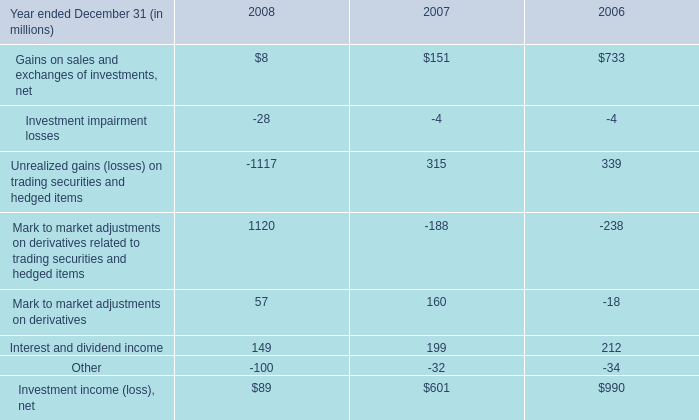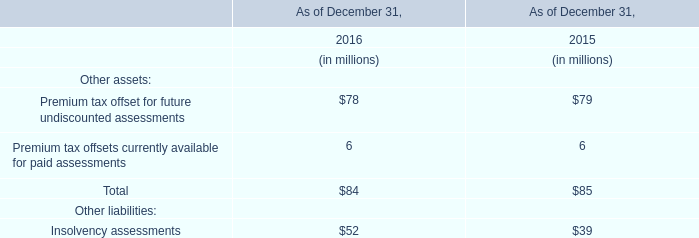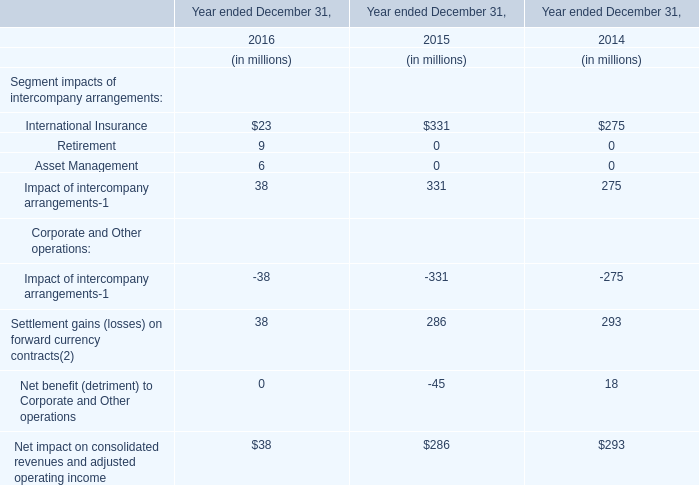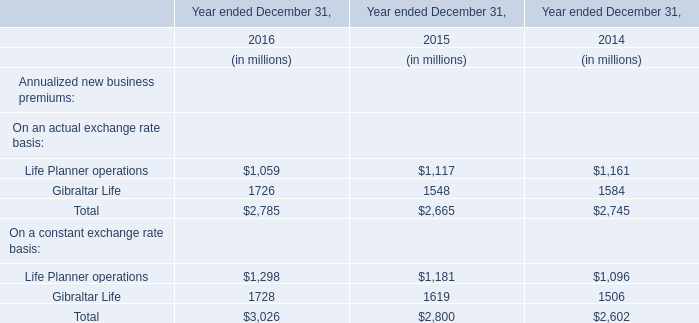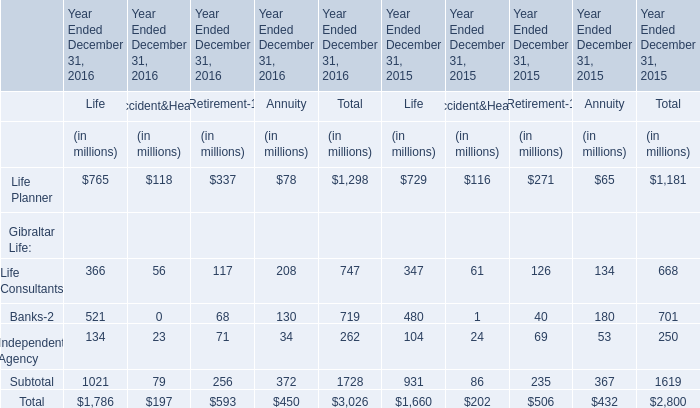In the year with largest amount of Life Planner for Life, what's the increasing rate of Banks-2 of Life? 
Computations: ((521 - 480) / 521)
Answer: 0.07869. 